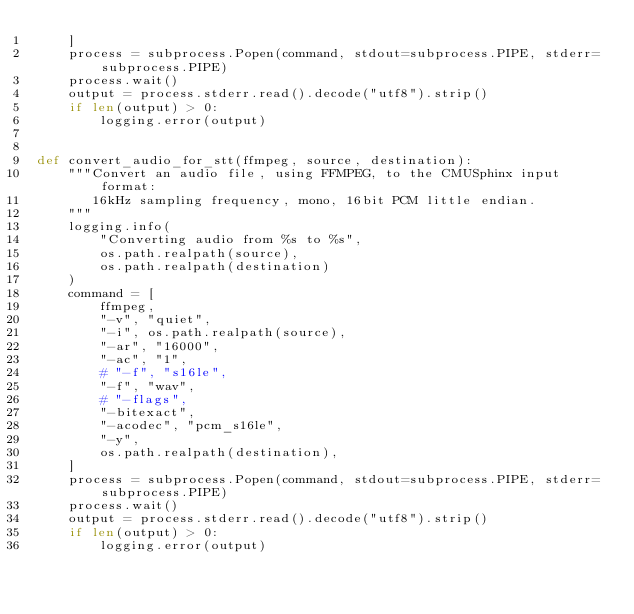<code> <loc_0><loc_0><loc_500><loc_500><_Python_>    ]
    process = subprocess.Popen(command, stdout=subprocess.PIPE, stderr=subprocess.PIPE)
    process.wait()
    output = process.stderr.read().decode("utf8").strip()
    if len(output) > 0:
        logging.error(output)


def convert_audio_for_stt(ffmpeg, source, destination):
    """Convert an audio file, using FFMPEG, to the CMUSphinx input format:
       16kHz sampling frequency, mono, 16bit PCM little endian.
    """
    logging.info(
        "Converting audio from %s to %s",
        os.path.realpath(source),
        os.path.realpath(destination)
    )
    command = [
        ffmpeg,
        "-v", "quiet",
        "-i", os.path.realpath(source),
        "-ar", "16000",
        "-ac", "1",
        # "-f", "s16le",
        "-f", "wav",
        # "-flags",
        "-bitexact",
        "-acodec", "pcm_s16le",
        "-y",
        os.path.realpath(destination),
    ]
    process = subprocess.Popen(command, stdout=subprocess.PIPE, stderr=subprocess.PIPE)
    process.wait()
    output = process.stderr.read().decode("utf8").strip()
    if len(output) > 0:
        logging.error(output)
</code> 